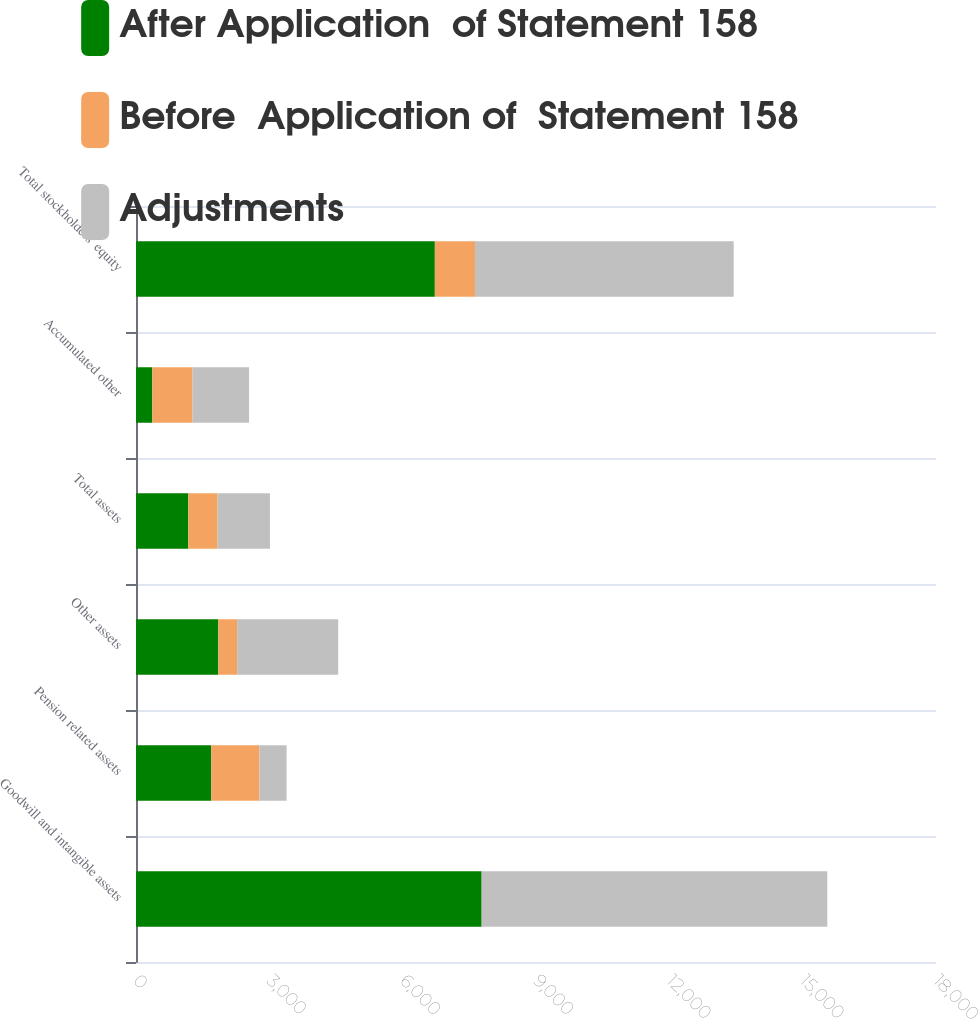Convert chart to OTSL. <chart><loc_0><loc_0><loc_500><loc_500><stacked_bar_chart><ecel><fcel>Goodwill and intangible assets<fcel>Pension related assets<fcel>Other assets<fcel>Total assets<fcel>Accumulated other<fcel>Total stockholders' equity<nl><fcel>After Application  of Statement 158<fcel>7777<fcel>1694<fcel>1852<fcel>1176.5<fcel>367<fcel>6724<nl><fcel>Before  Application of  Statement 158<fcel>2<fcel>1081<fcel>423<fcel>660<fcel>905<fcel>905<nl><fcel>Adjustments<fcel>7775<fcel>613<fcel>2275<fcel>1176.5<fcel>1272<fcel>5819<nl></chart> 